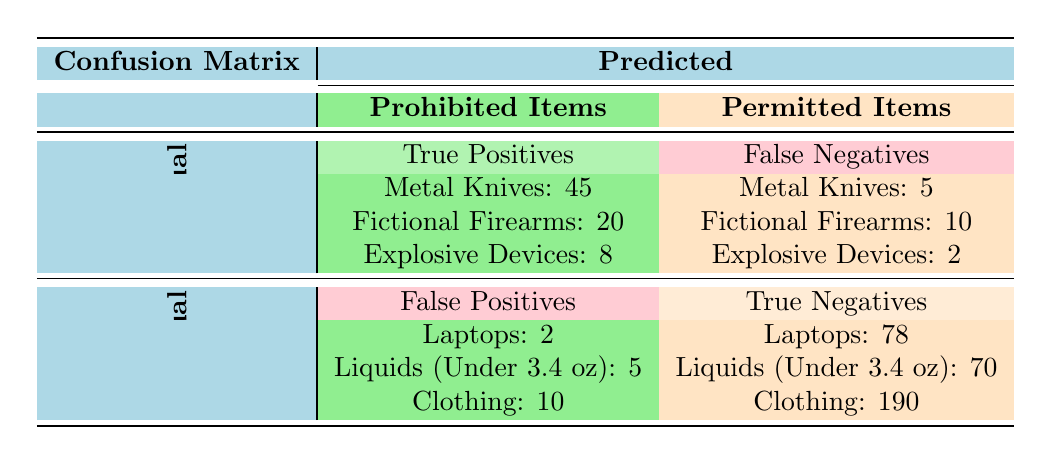What is the total number of Metal Knives identified? To find the total number of Metal Knives identified, we look at the True Positives category, where 45 Metal Knives are detected. Additionally, there are 5 False Negatives, which indicates that 5 Metal Knives were missed. Thus, the total is 45 + 5 = 50.
Answer: 50 How many False Positives were recorded for Clothing? The table shows that there were 10 False Positives for Clothing. This figure helps us understand how many items were incorrectly identified as prohibited when they were not.
Answer: 10 What is the total number of Permitted Items correctly identified (True Negatives)? We need to sum the True Negatives for each Permitted Item: Laptops (78) + Liquids (Under 3.4 oz) (70) + Clothing (190) = 78 + 70 + 190 = 338.
Answer: 338 Did the body scanner correctly identify more items as Prohibited than it missed? The scanner identified 45 True Positives and missed 5 (False Negatives), making a total of 50 Prohibited Items. Therefore, since 50 are seen (45 True Positives and a missed count) versus 50 total items, it identified items correctly but did not exceed.
Answer: No What is the proportion of False Negatives to the total number of Prohibited Items? The total Prohibited Items is 50 (10 Metal Knives, 30 Fictional Firearms, and 10 Explosive Devices). The False Negatives total is 5 (Metal Knives) + 10 (Fictional Firearms) + 2 (Explosive Devices) = 17. The proportion of False Negatives to Total Prohibited Items is 17/50, which can be calculated as 0.34 or 34%.
Answer: 34% 